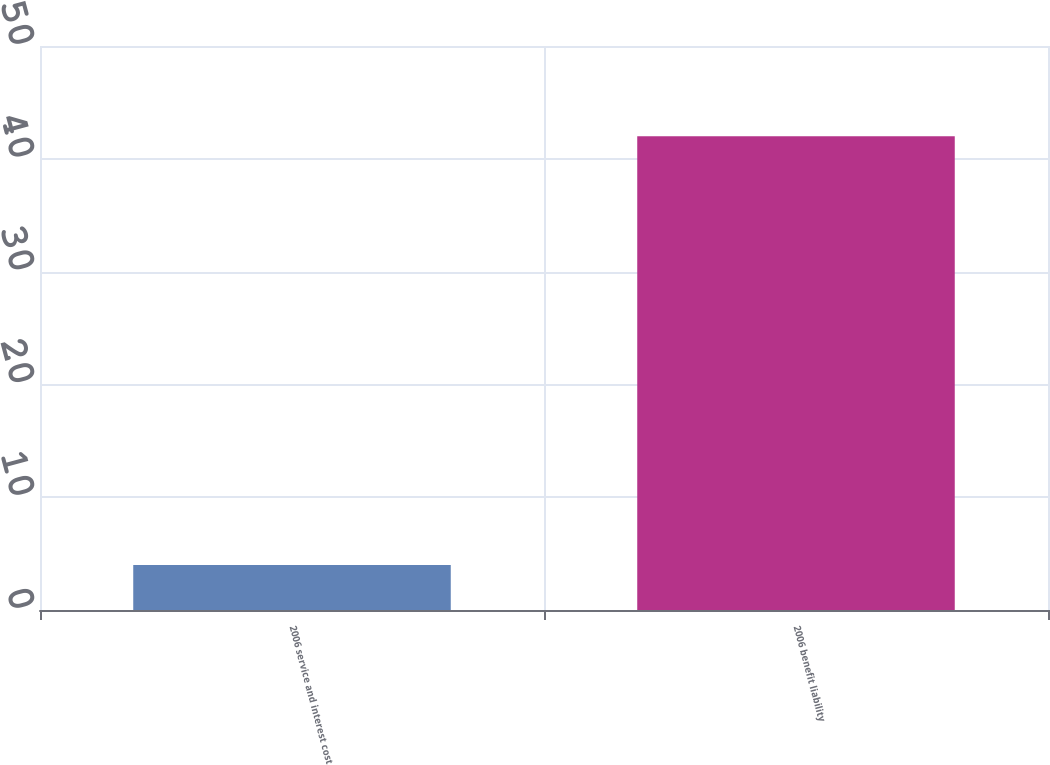Convert chart to OTSL. <chart><loc_0><loc_0><loc_500><loc_500><bar_chart><fcel>2006 service and interest cost<fcel>2006 benefit liability<nl><fcel>4<fcel>42<nl></chart> 